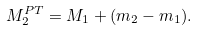<formula> <loc_0><loc_0><loc_500><loc_500>M _ { 2 } ^ { P T } = M _ { 1 } + ( m _ { 2 } - m _ { 1 } ) .</formula> 